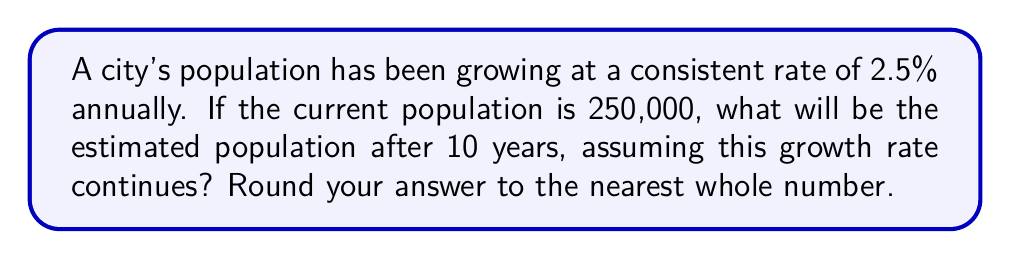Could you help me with this problem? To solve this problem, we'll use the geometric sequence formula for population growth:

$$P_n = P_0 \cdot (1 + r)^n$$

Where:
$P_n$ = Population after n years
$P_0$ = Initial population
$r$ = Annual growth rate (as a decimal)
$n$ = Number of years

Given:
$P_0 = 250,000$
$r = 0.025$ (2.5% expressed as a decimal)
$n = 10$ years

Step 1: Plug the values into the formula:
$$P_{10} = 250,000 \cdot (1 + 0.025)^{10}$$

Step 2: Simplify the expression inside the parentheses:
$$P_{10} = 250,000 \cdot (1.025)^{10}$$

Step 3: Calculate $(1.025)^{10}$:
$$(1.025)^{10} \approx 1.280085$$

Step 4: Multiply by the initial population:
$$P_{10} = 250,000 \cdot 1.280085 = 320,021.25$$

Step 5: Round to the nearest whole number:
$$P_{10} \approx 320,021$$
Answer: 320,021 